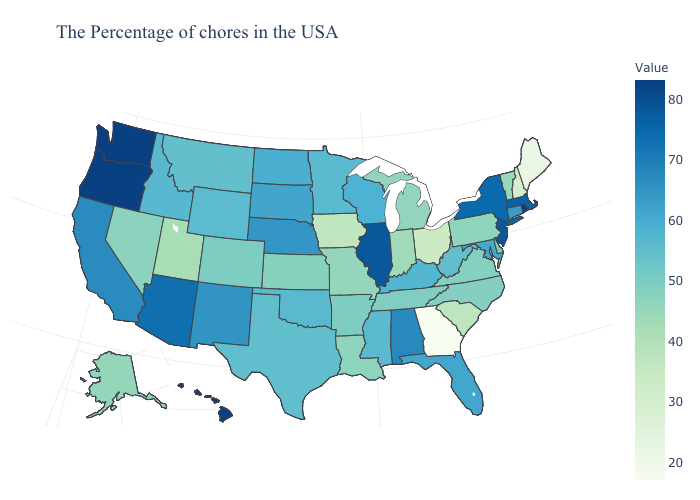Does Georgia have the lowest value in the South?
Write a very short answer. Yes. Does New Mexico have a higher value than New Jersey?
Keep it brief. No. Does the map have missing data?
Write a very short answer. No. Does Indiana have a higher value than Georgia?
Answer briefly. Yes. Among the states that border Texas , which have the lowest value?
Give a very brief answer. Louisiana. Does the map have missing data?
Concise answer only. No. Among the states that border Tennessee , does Arkansas have the highest value?
Keep it brief. No. Among the states that border Tennessee , does Alabama have the highest value?
Keep it brief. Yes. Among the states that border Ohio , does Kentucky have the highest value?
Keep it brief. Yes. 